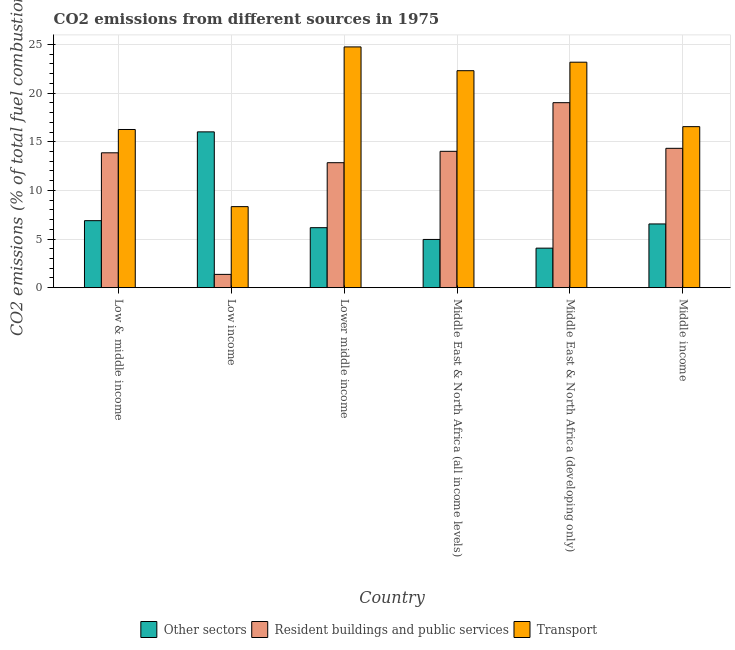How many different coloured bars are there?
Offer a very short reply. 3. In how many cases, is the number of bars for a given country not equal to the number of legend labels?
Your response must be concise. 0. What is the percentage of co2 emissions from transport in Low income?
Ensure brevity in your answer.  8.33. Across all countries, what is the maximum percentage of co2 emissions from transport?
Offer a very short reply. 24.75. Across all countries, what is the minimum percentage of co2 emissions from transport?
Your answer should be very brief. 8.33. In which country was the percentage of co2 emissions from resident buildings and public services maximum?
Provide a succinct answer. Middle East & North Africa (developing only). In which country was the percentage of co2 emissions from other sectors minimum?
Ensure brevity in your answer.  Middle East & North Africa (developing only). What is the total percentage of co2 emissions from transport in the graph?
Make the answer very short. 111.37. What is the difference between the percentage of co2 emissions from transport in Middle East & North Africa (all income levels) and that in Middle East & North Africa (developing only)?
Ensure brevity in your answer.  -0.87. What is the difference between the percentage of co2 emissions from other sectors in Low income and the percentage of co2 emissions from transport in Middle income?
Your answer should be compact. -0.54. What is the average percentage of co2 emissions from other sectors per country?
Your response must be concise. 7.44. What is the difference between the percentage of co2 emissions from resident buildings and public services and percentage of co2 emissions from other sectors in Low income?
Your answer should be very brief. -14.65. What is the ratio of the percentage of co2 emissions from transport in Low & middle income to that in Middle income?
Give a very brief answer. 0.98. What is the difference between the highest and the second highest percentage of co2 emissions from transport?
Ensure brevity in your answer.  1.57. What is the difference between the highest and the lowest percentage of co2 emissions from resident buildings and public services?
Make the answer very short. 17.65. In how many countries, is the percentage of co2 emissions from transport greater than the average percentage of co2 emissions from transport taken over all countries?
Offer a very short reply. 3. What does the 1st bar from the left in Middle East & North Africa (all income levels) represents?
Offer a very short reply. Other sectors. What does the 2nd bar from the right in Lower middle income represents?
Keep it short and to the point. Resident buildings and public services. How many bars are there?
Give a very brief answer. 18. Are the values on the major ticks of Y-axis written in scientific E-notation?
Offer a terse response. No. Where does the legend appear in the graph?
Provide a short and direct response. Bottom center. How many legend labels are there?
Offer a very short reply. 3. How are the legend labels stacked?
Your answer should be very brief. Horizontal. What is the title of the graph?
Give a very brief answer. CO2 emissions from different sources in 1975. What is the label or title of the Y-axis?
Give a very brief answer. CO2 emissions (% of total fuel combustion). What is the CO2 emissions (% of total fuel combustion) of Other sectors in Low & middle income?
Offer a terse response. 6.89. What is the CO2 emissions (% of total fuel combustion) of Resident buildings and public services in Low & middle income?
Your answer should be compact. 13.86. What is the CO2 emissions (% of total fuel combustion) of Transport in Low & middle income?
Keep it short and to the point. 16.26. What is the CO2 emissions (% of total fuel combustion) of Other sectors in Low income?
Provide a succinct answer. 16.01. What is the CO2 emissions (% of total fuel combustion) in Resident buildings and public services in Low income?
Offer a terse response. 1.37. What is the CO2 emissions (% of total fuel combustion) in Transport in Low income?
Your response must be concise. 8.33. What is the CO2 emissions (% of total fuel combustion) in Other sectors in Lower middle income?
Keep it short and to the point. 6.17. What is the CO2 emissions (% of total fuel combustion) in Resident buildings and public services in Lower middle income?
Your answer should be compact. 12.85. What is the CO2 emissions (% of total fuel combustion) of Transport in Lower middle income?
Provide a succinct answer. 24.75. What is the CO2 emissions (% of total fuel combustion) in Other sectors in Middle East & North Africa (all income levels)?
Provide a succinct answer. 4.96. What is the CO2 emissions (% of total fuel combustion) in Resident buildings and public services in Middle East & North Africa (all income levels)?
Your answer should be compact. 14.01. What is the CO2 emissions (% of total fuel combustion) of Transport in Middle East & North Africa (all income levels)?
Offer a very short reply. 22.3. What is the CO2 emissions (% of total fuel combustion) of Other sectors in Middle East & North Africa (developing only)?
Give a very brief answer. 4.06. What is the CO2 emissions (% of total fuel combustion) of Resident buildings and public services in Middle East & North Africa (developing only)?
Your answer should be very brief. 19.01. What is the CO2 emissions (% of total fuel combustion) of Transport in Middle East & North Africa (developing only)?
Provide a succinct answer. 23.18. What is the CO2 emissions (% of total fuel combustion) in Other sectors in Middle income?
Your response must be concise. 6.55. What is the CO2 emissions (% of total fuel combustion) in Resident buildings and public services in Middle income?
Provide a succinct answer. 14.32. What is the CO2 emissions (% of total fuel combustion) of Transport in Middle income?
Ensure brevity in your answer.  16.55. Across all countries, what is the maximum CO2 emissions (% of total fuel combustion) of Other sectors?
Your answer should be very brief. 16.01. Across all countries, what is the maximum CO2 emissions (% of total fuel combustion) of Resident buildings and public services?
Provide a short and direct response. 19.01. Across all countries, what is the maximum CO2 emissions (% of total fuel combustion) of Transport?
Make the answer very short. 24.75. Across all countries, what is the minimum CO2 emissions (% of total fuel combustion) in Other sectors?
Provide a succinct answer. 4.06. Across all countries, what is the minimum CO2 emissions (% of total fuel combustion) of Resident buildings and public services?
Ensure brevity in your answer.  1.37. Across all countries, what is the minimum CO2 emissions (% of total fuel combustion) in Transport?
Provide a short and direct response. 8.33. What is the total CO2 emissions (% of total fuel combustion) of Other sectors in the graph?
Give a very brief answer. 44.64. What is the total CO2 emissions (% of total fuel combustion) in Resident buildings and public services in the graph?
Make the answer very short. 75.43. What is the total CO2 emissions (% of total fuel combustion) of Transport in the graph?
Your answer should be very brief. 111.37. What is the difference between the CO2 emissions (% of total fuel combustion) of Other sectors in Low & middle income and that in Low income?
Offer a terse response. -9.13. What is the difference between the CO2 emissions (% of total fuel combustion) of Resident buildings and public services in Low & middle income and that in Low income?
Offer a very short reply. 12.5. What is the difference between the CO2 emissions (% of total fuel combustion) in Transport in Low & middle income and that in Low income?
Offer a terse response. 7.93. What is the difference between the CO2 emissions (% of total fuel combustion) of Other sectors in Low & middle income and that in Lower middle income?
Give a very brief answer. 0.72. What is the difference between the CO2 emissions (% of total fuel combustion) of Resident buildings and public services in Low & middle income and that in Lower middle income?
Ensure brevity in your answer.  1.02. What is the difference between the CO2 emissions (% of total fuel combustion) in Transport in Low & middle income and that in Lower middle income?
Make the answer very short. -8.49. What is the difference between the CO2 emissions (% of total fuel combustion) in Other sectors in Low & middle income and that in Middle East & North Africa (all income levels)?
Ensure brevity in your answer.  1.93. What is the difference between the CO2 emissions (% of total fuel combustion) in Resident buildings and public services in Low & middle income and that in Middle East & North Africa (all income levels)?
Your answer should be compact. -0.15. What is the difference between the CO2 emissions (% of total fuel combustion) of Transport in Low & middle income and that in Middle East & North Africa (all income levels)?
Offer a terse response. -6.04. What is the difference between the CO2 emissions (% of total fuel combustion) in Other sectors in Low & middle income and that in Middle East & North Africa (developing only)?
Offer a terse response. 2.82. What is the difference between the CO2 emissions (% of total fuel combustion) in Resident buildings and public services in Low & middle income and that in Middle East & North Africa (developing only)?
Ensure brevity in your answer.  -5.15. What is the difference between the CO2 emissions (% of total fuel combustion) of Transport in Low & middle income and that in Middle East & North Africa (developing only)?
Make the answer very short. -6.92. What is the difference between the CO2 emissions (% of total fuel combustion) of Other sectors in Low & middle income and that in Middle income?
Provide a succinct answer. 0.34. What is the difference between the CO2 emissions (% of total fuel combustion) in Resident buildings and public services in Low & middle income and that in Middle income?
Make the answer very short. -0.46. What is the difference between the CO2 emissions (% of total fuel combustion) of Transport in Low & middle income and that in Middle income?
Your answer should be very brief. -0.29. What is the difference between the CO2 emissions (% of total fuel combustion) in Other sectors in Low income and that in Lower middle income?
Keep it short and to the point. 9.85. What is the difference between the CO2 emissions (% of total fuel combustion) in Resident buildings and public services in Low income and that in Lower middle income?
Ensure brevity in your answer.  -11.48. What is the difference between the CO2 emissions (% of total fuel combustion) of Transport in Low income and that in Lower middle income?
Your answer should be very brief. -16.42. What is the difference between the CO2 emissions (% of total fuel combustion) of Other sectors in Low income and that in Middle East & North Africa (all income levels)?
Your answer should be very brief. 11.06. What is the difference between the CO2 emissions (% of total fuel combustion) of Resident buildings and public services in Low income and that in Middle East & North Africa (all income levels)?
Provide a succinct answer. -12.65. What is the difference between the CO2 emissions (% of total fuel combustion) of Transport in Low income and that in Middle East & North Africa (all income levels)?
Offer a terse response. -13.97. What is the difference between the CO2 emissions (% of total fuel combustion) in Other sectors in Low income and that in Middle East & North Africa (developing only)?
Keep it short and to the point. 11.95. What is the difference between the CO2 emissions (% of total fuel combustion) of Resident buildings and public services in Low income and that in Middle East & North Africa (developing only)?
Ensure brevity in your answer.  -17.65. What is the difference between the CO2 emissions (% of total fuel combustion) in Transport in Low income and that in Middle East & North Africa (developing only)?
Your answer should be very brief. -14.85. What is the difference between the CO2 emissions (% of total fuel combustion) of Other sectors in Low income and that in Middle income?
Your response must be concise. 9.46. What is the difference between the CO2 emissions (% of total fuel combustion) in Resident buildings and public services in Low income and that in Middle income?
Your response must be concise. -12.96. What is the difference between the CO2 emissions (% of total fuel combustion) of Transport in Low income and that in Middle income?
Give a very brief answer. -8.22. What is the difference between the CO2 emissions (% of total fuel combustion) in Other sectors in Lower middle income and that in Middle East & North Africa (all income levels)?
Your answer should be compact. 1.21. What is the difference between the CO2 emissions (% of total fuel combustion) in Resident buildings and public services in Lower middle income and that in Middle East & North Africa (all income levels)?
Your response must be concise. -1.17. What is the difference between the CO2 emissions (% of total fuel combustion) in Transport in Lower middle income and that in Middle East & North Africa (all income levels)?
Offer a terse response. 2.44. What is the difference between the CO2 emissions (% of total fuel combustion) of Other sectors in Lower middle income and that in Middle East & North Africa (developing only)?
Keep it short and to the point. 2.1. What is the difference between the CO2 emissions (% of total fuel combustion) of Resident buildings and public services in Lower middle income and that in Middle East & North Africa (developing only)?
Your answer should be compact. -6.17. What is the difference between the CO2 emissions (% of total fuel combustion) in Transport in Lower middle income and that in Middle East & North Africa (developing only)?
Your response must be concise. 1.57. What is the difference between the CO2 emissions (% of total fuel combustion) in Other sectors in Lower middle income and that in Middle income?
Offer a terse response. -0.38. What is the difference between the CO2 emissions (% of total fuel combustion) of Resident buildings and public services in Lower middle income and that in Middle income?
Your answer should be very brief. -1.48. What is the difference between the CO2 emissions (% of total fuel combustion) in Transport in Lower middle income and that in Middle income?
Provide a succinct answer. 8.2. What is the difference between the CO2 emissions (% of total fuel combustion) in Other sectors in Middle East & North Africa (all income levels) and that in Middle East & North Africa (developing only)?
Your answer should be compact. 0.89. What is the difference between the CO2 emissions (% of total fuel combustion) of Resident buildings and public services in Middle East & North Africa (all income levels) and that in Middle East & North Africa (developing only)?
Your response must be concise. -5. What is the difference between the CO2 emissions (% of total fuel combustion) in Transport in Middle East & North Africa (all income levels) and that in Middle East & North Africa (developing only)?
Keep it short and to the point. -0.87. What is the difference between the CO2 emissions (% of total fuel combustion) of Other sectors in Middle East & North Africa (all income levels) and that in Middle income?
Ensure brevity in your answer.  -1.59. What is the difference between the CO2 emissions (% of total fuel combustion) of Resident buildings and public services in Middle East & North Africa (all income levels) and that in Middle income?
Your response must be concise. -0.31. What is the difference between the CO2 emissions (% of total fuel combustion) of Transport in Middle East & North Africa (all income levels) and that in Middle income?
Provide a succinct answer. 5.75. What is the difference between the CO2 emissions (% of total fuel combustion) of Other sectors in Middle East & North Africa (developing only) and that in Middle income?
Keep it short and to the point. -2.49. What is the difference between the CO2 emissions (% of total fuel combustion) of Resident buildings and public services in Middle East & North Africa (developing only) and that in Middle income?
Your answer should be compact. 4.69. What is the difference between the CO2 emissions (% of total fuel combustion) of Transport in Middle East & North Africa (developing only) and that in Middle income?
Provide a short and direct response. 6.63. What is the difference between the CO2 emissions (% of total fuel combustion) in Other sectors in Low & middle income and the CO2 emissions (% of total fuel combustion) in Resident buildings and public services in Low income?
Your answer should be compact. 5.52. What is the difference between the CO2 emissions (% of total fuel combustion) of Other sectors in Low & middle income and the CO2 emissions (% of total fuel combustion) of Transport in Low income?
Offer a very short reply. -1.44. What is the difference between the CO2 emissions (% of total fuel combustion) in Resident buildings and public services in Low & middle income and the CO2 emissions (% of total fuel combustion) in Transport in Low income?
Provide a succinct answer. 5.53. What is the difference between the CO2 emissions (% of total fuel combustion) of Other sectors in Low & middle income and the CO2 emissions (% of total fuel combustion) of Resident buildings and public services in Lower middle income?
Ensure brevity in your answer.  -5.96. What is the difference between the CO2 emissions (% of total fuel combustion) in Other sectors in Low & middle income and the CO2 emissions (% of total fuel combustion) in Transport in Lower middle income?
Offer a very short reply. -17.86. What is the difference between the CO2 emissions (% of total fuel combustion) of Resident buildings and public services in Low & middle income and the CO2 emissions (% of total fuel combustion) of Transport in Lower middle income?
Provide a short and direct response. -10.88. What is the difference between the CO2 emissions (% of total fuel combustion) of Other sectors in Low & middle income and the CO2 emissions (% of total fuel combustion) of Resident buildings and public services in Middle East & North Africa (all income levels)?
Ensure brevity in your answer.  -7.13. What is the difference between the CO2 emissions (% of total fuel combustion) in Other sectors in Low & middle income and the CO2 emissions (% of total fuel combustion) in Transport in Middle East & North Africa (all income levels)?
Offer a terse response. -15.42. What is the difference between the CO2 emissions (% of total fuel combustion) in Resident buildings and public services in Low & middle income and the CO2 emissions (% of total fuel combustion) in Transport in Middle East & North Africa (all income levels)?
Offer a terse response. -8.44. What is the difference between the CO2 emissions (% of total fuel combustion) in Other sectors in Low & middle income and the CO2 emissions (% of total fuel combustion) in Resident buildings and public services in Middle East & North Africa (developing only)?
Ensure brevity in your answer.  -12.13. What is the difference between the CO2 emissions (% of total fuel combustion) in Other sectors in Low & middle income and the CO2 emissions (% of total fuel combustion) in Transport in Middle East & North Africa (developing only)?
Offer a terse response. -16.29. What is the difference between the CO2 emissions (% of total fuel combustion) in Resident buildings and public services in Low & middle income and the CO2 emissions (% of total fuel combustion) in Transport in Middle East & North Africa (developing only)?
Your response must be concise. -9.31. What is the difference between the CO2 emissions (% of total fuel combustion) in Other sectors in Low & middle income and the CO2 emissions (% of total fuel combustion) in Resident buildings and public services in Middle income?
Provide a short and direct response. -7.44. What is the difference between the CO2 emissions (% of total fuel combustion) in Other sectors in Low & middle income and the CO2 emissions (% of total fuel combustion) in Transport in Middle income?
Your response must be concise. -9.66. What is the difference between the CO2 emissions (% of total fuel combustion) of Resident buildings and public services in Low & middle income and the CO2 emissions (% of total fuel combustion) of Transport in Middle income?
Give a very brief answer. -2.69. What is the difference between the CO2 emissions (% of total fuel combustion) in Other sectors in Low income and the CO2 emissions (% of total fuel combustion) in Resident buildings and public services in Lower middle income?
Ensure brevity in your answer.  3.17. What is the difference between the CO2 emissions (% of total fuel combustion) of Other sectors in Low income and the CO2 emissions (% of total fuel combustion) of Transport in Lower middle income?
Offer a terse response. -8.73. What is the difference between the CO2 emissions (% of total fuel combustion) in Resident buildings and public services in Low income and the CO2 emissions (% of total fuel combustion) in Transport in Lower middle income?
Ensure brevity in your answer.  -23.38. What is the difference between the CO2 emissions (% of total fuel combustion) in Other sectors in Low income and the CO2 emissions (% of total fuel combustion) in Resident buildings and public services in Middle East & North Africa (all income levels)?
Your answer should be very brief. 2. What is the difference between the CO2 emissions (% of total fuel combustion) of Other sectors in Low income and the CO2 emissions (% of total fuel combustion) of Transport in Middle East & North Africa (all income levels)?
Keep it short and to the point. -6.29. What is the difference between the CO2 emissions (% of total fuel combustion) of Resident buildings and public services in Low income and the CO2 emissions (% of total fuel combustion) of Transport in Middle East & North Africa (all income levels)?
Ensure brevity in your answer.  -20.94. What is the difference between the CO2 emissions (% of total fuel combustion) of Other sectors in Low income and the CO2 emissions (% of total fuel combustion) of Resident buildings and public services in Middle East & North Africa (developing only)?
Your response must be concise. -3. What is the difference between the CO2 emissions (% of total fuel combustion) in Other sectors in Low income and the CO2 emissions (% of total fuel combustion) in Transport in Middle East & North Africa (developing only)?
Your answer should be very brief. -7.16. What is the difference between the CO2 emissions (% of total fuel combustion) in Resident buildings and public services in Low income and the CO2 emissions (% of total fuel combustion) in Transport in Middle East & North Africa (developing only)?
Make the answer very short. -21.81. What is the difference between the CO2 emissions (% of total fuel combustion) in Other sectors in Low income and the CO2 emissions (% of total fuel combustion) in Resident buildings and public services in Middle income?
Your response must be concise. 1.69. What is the difference between the CO2 emissions (% of total fuel combustion) of Other sectors in Low income and the CO2 emissions (% of total fuel combustion) of Transport in Middle income?
Make the answer very short. -0.54. What is the difference between the CO2 emissions (% of total fuel combustion) of Resident buildings and public services in Low income and the CO2 emissions (% of total fuel combustion) of Transport in Middle income?
Give a very brief answer. -15.19. What is the difference between the CO2 emissions (% of total fuel combustion) of Other sectors in Lower middle income and the CO2 emissions (% of total fuel combustion) of Resident buildings and public services in Middle East & North Africa (all income levels)?
Provide a short and direct response. -7.85. What is the difference between the CO2 emissions (% of total fuel combustion) in Other sectors in Lower middle income and the CO2 emissions (% of total fuel combustion) in Transport in Middle East & North Africa (all income levels)?
Your answer should be very brief. -16.14. What is the difference between the CO2 emissions (% of total fuel combustion) of Resident buildings and public services in Lower middle income and the CO2 emissions (% of total fuel combustion) of Transport in Middle East & North Africa (all income levels)?
Make the answer very short. -9.46. What is the difference between the CO2 emissions (% of total fuel combustion) in Other sectors in Lower middle income and the CO2 emissions (% of total fuel combustion) in Resident buildings and public services in Middle East & North Africa (developing only)?
Offer a very short reply. -12.85. What is the difference between the CO2 emissions (% of total fuel combustion) in Other sectors in Lower middle income and the CO2 emissions (% of total fuel combustion) in Transport in Middle East & North Africa (developing only)?
Ensure brevity in your answer.  -17.01. What is the difference between the CO2 emissions (% of total fuel combustion) in Resident buildings and public services in Lower middle income and the CO2 emissions (% of total fuel combustion) in Transport in Middle East & North Africa (developing only)?
Provide a short and direct response. -10.33. What is the difference between the CO2 emissions (% of total fuel combustion) in Other sectors in Lower middle income and the CO2 emissions (% of total fuel combustion) in Resident buildings and public services in Middle income?
Provide a short and direct response. -8.16. What is the difference between the CO2 emissions (% of total fuel combustion) of Other sectors in Lower middle income and the CO2 emissions (% of total fuel combustion) of Transport in Middle income?
Your answer should be compact. -10.39. What is the difference between the CO2 emissions (% of total fuel combustion) of Resident buildings and public services in Lower middle income and the CO2 emissions (% of total fuel combustion) of Transport in Middle income?
Provide a short and direct response. -3.71. What is the difference between the CO2 emissions (% of total fuel combustion) in Other sectors in Middle East & North Africa (all income levels) and the CO2 emissions (% of total fuel combustion) in Resident buildings and public services in Middle East & North Africa (developing only)?
Make the answer very short. -14.06. What is the difference between the CO2 emissions (% of total fuel combustion) of Other sectors in Middle East & North Africa (all income levels) and the CO2 emissions (% of total fuel combustion) of Transport in Middle East & North Africa (developing only)?
Your response must be concise. -18.22. What is the difference between the CO2 emissions (% of total fuel combustion) of Resident buildings and public services in Middle East & North Africa (all income levels) and the CO2 emissions (% of total fuel combustion) of Transport in Middle East & North Africa (developing only)?
Your response must be concise. -9.16. What is the difference between the CO2 emissions (% of total fuel combustion) in Other sectors in Middle East & North Africa (all income levels) and the CO2 emissions (% of total fuel combustion) in Resident buildings and public services in Middle income?
Give a very brief answer. -9.37. What is the difference between the CO2 emissions (% of total fuel combustion) in Other sectors in Middle East & North Africa (all income levels) and the CO2 emissions (% of total fuel combustion) in Transport in Middle income?
Make the answer very short. -11.59. What is the difference between the CO2 emissions (% of total fuel combustion) of Resident buildings and public services in Middle East & North Africa (all income levels) and the CO2 emissions (% of total fuel combustion) of Transport in Middle income?
Keep it short and to the point. -2.54. What is the difference between the CO2 emissions (% of total fuel combustion) in Other sectors in Middle East & North Africa (developing only) and the CO2 emissions (% of total fuel combustion) in Resident buildings and public services in Middle income?
Make the answer very short. -10.26. What is the difference between the CO2 emissions (% of total fuel combustion) of Other sectors in Middle East & North Africa (developing only) and the CO2 emissions (% of total fuel combustion) of Transport in Middle income?
Ensure brevity in your answer.  -12.49. What is the difference between the CO2 emissions (% of total fuel combustion) in Resident buildings and public services in Middle East & North Africa (developing only) and the CO2 emissions (% of total fuel combustion) in Transport in Middle income?
Make the answer very short. 2.46. What is the average CO2 emissions (% of total fuel combustion) in Other sectors per country?
Your answer should be very brief. 7.44. What is the average CO2 emissions (% of total fuel combustion) of Resident buildings and public services per country?
Make the answer very short. 12.57. What is the average CO2 emissions (% of total fuel combustion) of Transport per country?
Your answer should be very brief. 18.56. What is the difference between the CO2 emissions (% of total fuel combustion) in Other sectors and CO2 emissions (% of total fuel combustion) in Resident buildings and public services in Low & middle income?
Offer a terse response. -6.98. What is the difference between the CO2 emissions (% of total fuel combustion) in Other sectors and CO2 emissions (% of total fuel combustion) in Transport in Low & middle income?
Provide a succinct answer. -9.37. What is the difference between the CO2 emissions (% of total fuel combustion) of Resident buildings and public services and CO2 emissions (% of total fuel combustion) of Transport in Low & middle income?
Provide a short and direct response. -2.4. What is the difference between the CO2 emissions (% of total fuel combustion) of Other sectors and CO2 emissions (% of total fuel combustion) of Resident buildings and public services in Low income?
Give a very brief answer. 14.65. What is the difference between the CO2 emissions (% of total fuel combustion) of Other sectors and CO2 emissions (% of total fuel combustion) of Transport in Low income?
Ensure brevity in your answer.  7.68. What is the difference between the CO2 emissions (% of total fuel combustion) of Resident buildings and public services and CO2 emissions (% of total fuel combustion) of Transport in Low income?
Provide a succinct answer. -6.96. What is the difference between the CO2 emissions (% of total fuel combustion) of Other sectors and CO2 emissions (% of total fuel combustion) of Resident buildings and public services in Lower middle income?
Offer a very short reply. -6.68. What is the difference between the CO2 emissions (% of total fuel combustion) of Other sectors and CO2 emissions (% of total fuel combustion) of Transport in Lower middle income?
Make the answer very short. -18.58. What is the difference between the CO2 emissions (% of total fuel combustion) of Resident buildings and public services and CO2 emissions (% of total fuel combustion) of Transport in Lower middle income?
Provide a succinct answer. -11.9. What is the difference between the CO2 emissions (% of total fuel combustion) of Other sectors and CO2 emissions (% of total fuel combustion) of Resident buildings and public services in Middle East & North Africa (all income levels)?
Your response must be concise. -9.06. What is the difference between the CO2 emissions (% of total fuel combustion) of Other sectors and CO2 emissions (% of total fuel combustion) of Transport in Middle East & North Africa (all income levels)?
Give a very brief answer. -17.35. What is the difference between the CO2 emissions (% of total fuel combustion) of Resident buildings and public services and CO2 emissions (% of total fuel combustion) of Transport in Middle East & North Africa (all income levels)?
Your answer should be compact. -8.29. What is the difference between the CO2 emissions (% of total fuel combustion) in Other sectors and CO2 emissions (% of total fuel combustion) in Resident buildings and public services in Middle East & North Africa (developing only)?
Your response must be concise. -14.95. What is the difference between the CO2 emissions (% of total fuel combustion) in Other sectors and CO2 emissions (% of total fuel combustion) in Transport in Middle East & North Africa (developing only)?
Make the answer very short. -19.11. What is the difference between the CO2 emissions (% of total fuel combustion) in Resident buildings and public services and CO2 emissions (% of total fuel combustion) in Transport in Middle East & North Africa (developing only)?
Provide a short and direct response. -4.16. What is the difference between the CO2 emissions (% of total fuel combustion) of Other sectors and CO2 emissions (% of total fuel combustion) of Resident buildings and public services in Middle income?
Offer a very short reply. -7.77. What is the difference between the CO2 emissions (% of total fuel combustion) in Other sectors and CO2 emissions (% of total fuel combustion) in Transport in Middle income?
Your response must be concise. -10. What is the difference between the CO2 emissions (% of total fuel combustion) of Resident buildings and public services and CO2 emissions (% of total fuel combustion) of Transport in Middle income?
Keep it short and to the point. -2.23. What is the ratio of the CO2 emissions (% of total fuel combustion) of Other sectors in Low & middle income to that in Low income?
Your response must be concise. 0.43. What is the ratio of the CO2 emissions (% of total fuel combustion) of Resident buildings and public services in Low & middle income to that in Low income?
Your answer should be compact. 10.16. What is the ratio of the CO2 emissions (% of total fuel combustion) in Transport in Low & middle income to that in Low income?
Provide a succinct answer. 1.95. What is the ratio of the CO2 emissions (% of total fuel combustion) of Other sectors in Low & middle income to that in Lower middle income?
Offer a very short reply. 1.12. What is the ratio of the CO2 emissions (% of total fuel combustion) of Resident buildings and public services in Low & middle income to that in Lower middle income?
Ensure brevity in your answer.  1.08. What is the ratio of the CO2 emissions (% of total fuel combustion) in Transport in Low & middle income to that in Lower middle income?
Offer a very short reply. 0.66. What is the ratio of the CO2 emissions (% of total fuel combustion) in Other sectors in Low & middle income to that in Middle East & North Africa (all income levels)?
Ensure brevity in your answer.  1.39. What is the ratio of the CO2 emissions (% of total fuel combustion) in Transport in Low & middle income to that in Middle East & North Africa (all income levels)?
Offer a very short reply. 0.73. What is the ratio of the CO2 emissions (% of total fuel combustion) in Other sectors in Low & middle income to that in Middle East & North Africa (developing only)?
Your response must be concise. 1.7. What is the ratio of the CO2 emissions (% of total fuel combustion) of Resident buildings and public services in Low & middle income to that in Middle East & North Africa (developing only)?
Offer a terse response. 0.73. What is the ratio of the CO2 emissions (% of total fuel combustion) in Transport in Low & middle income to that in Middle East & North Africa (developing only)?
Your answer should be compact. 0.7. What is the ratio of the CO2 emissions (% of total fuel combustion) in Other sectors in Low & middle income to that in Middle income?
Provide a short and direct response. 1.05. What is the ratio of the CO2 emissions (% of total fuel combustion) of Resident buildings and public services in Low & middle income to that in Middle income?
Ensure brevity in your answer.  0.97. What is the ratio of the CO2 emissions (% of total fuel combustion) of Transport in Low & middle income to that in Middle income?
Offer a very short reply. 0.98. What is the ratio of the CO2 emissions (% of total fuel combustion) in Other sectors in Low income to that in Lower middle income?
Provide a succinct answer. 2.6. What is the ratio of the CO2 emissions (% of total fuel combustion) in Resident buildings and public services in Low income to that in Lower middle income?
Your answer should be compact. 0.11. What is the ratio of the CO2 emissions (% of total fuel combustion) of Transport in Low income to that in Lower middle income?
Offer a terse response. 0.34. What is the ratio of the CO2 emissions (% of total fuel combustion) in Other sectors in Low income to that in Middle East & North Africa (all income levels)?
Keep it short and to the point. 3.23. What is the ratio of the CO2 emissions (% of total fuel combustion) of Resident buildings and public services in Low income to that in Middle East & North Africa (all income levels)?
Offer a very short reply. 0.1. What is the ratio of the CO2 emissions (% of total fuel combustion) of Transport in Low income to that in Middle East & North Africa (all income levels)?
Your answer should be very brief. 0.37. What is the ratio of the CO2 emissions (% of total fuel combustion) of Other sectors in Low income to that in Middle East & North Africa (developing only)?
Offer a very short reply. 3.94. What is the ratio of the CO2 emissions (% of total fuel combustion) of Resident buildings and public services in Low income to that in Middle East & North Africa (developing only)?
Make the answer very short. 0.07. What is the ratio of the CO2 emissions (% of total fuel combustion) of Transport in Low income to that in Middle East & North Africa (developing only)?
Your response must be concise. 0.36. What is the ratio of the CO2 emissions (% of total fuel combustion) in Other sectors in Low income to that in Middle income?
Keep it short and to the point. 2.44. What is the ratio of the CO2 emissions (% of total fuel combustion) in Resident buildings and public services in Low income to that in Middle income?
Provide a succinct answer. 0.1. What is the ratio of the CO2 emissions (% of total fuel combustion) in Transport in Low income to that in Middle income?
Offer a terse response. 0.5. What is the ratio of the CO2 emissions (% of total fuel combustion) in Other sectors in Lower middle income to that in Middle East & North Africa (all income levels)?
Ensure brevity in your answer.  1.24. What is the ratio of the CO2 emissions (% of total fuel combustion) in Resident buildings and public services in Lower middle income to that in Middle East & North Africa (all income levels)?
Offer a very short reply. 0.92. What is the ratio of the CO2 emissions (% of total fuel combustion) of Transport in Lower middle income to that in Middle East & North Africa (all income levels)?
Make the answer very short. 1.11. What is the ratio of the CO2 emissions (% of total fuel combustion) of Other sectors in Lower middle income to that in Middle East & North Africa (developing only)?
Offer a very short reply. 1.52. What is the ratio of the CO2 emissions (% of total fuel combustion) of Resident buildings and public services in Lower middle income to that in Middle East & North Africa (developing only)?
Offer a terse response. 0.68. What is the ratio of the CO2 emissions (% of total fuel combustion) in Transport in Lower middle income to that in Middle East & North Africa (developing only)?
Your answer should be compact. 1.07. What is the ratio of the CO2 emissions (% of total fuel combustion) of Other sectors in Lower middle income to that in Middle income?
Your answer should be compact. 0.94. What is the ratio of the CO2 emissions (% of total fuel combustion) in Resident buildings and public services in Lower middle income to that in Middle income?
Offer a very short reply. 0.9. What is the ratio of the CO2 emissions (% of total fuel combustion) in Transport in Lower middle income to that in Middle income?
Your answer should be very brief. 1.5. What is the ratio of the CO2 emissions (% of total fuel combustion) in Other sectors in Middle East & North Africa (all income levels) to that in Middle East & North Africa (developing only)?
Your response must be concise. 1.22. What is the ratio of the CO2 emissions (% of total fuel combustion) of Resident buildings and public services in Middle East & North Africa (all income levels) to that in Middle East & North Africa (developing only)?
Offer a very short reply. 0.74. What is the ratio of the CO2 emissions (% of total fuel combustion) of Transport in Middle East & North Africa (all income levels) to that in Middle East & North Africa (developing only)?
Your answer should be compact. 0.96. What is the ratio of the CO2 emissions (% of total fuel combustion) of Other sectors in Middle East & North Africa (all income levels) to that in Middle income?
Ensure brevity in your answer.  0.76. What is the ratio of the CO2 emissions (% of total fuel combustion) of Resident buildings and public services in Middle East & North Africa (all income levels) to that in Middle income?
Give a very brief answer. 0.98. What is the ratio of the CO2 emissions (% of total fuel combustion) of Transport in Middle East & North Africa (all income levels) to that in Middle income?
Keep it short and to the point. 1.35. What is the ratio of the CO2 emissions (% of total fuel combustion) of Other sectors in Middle East & North Africa (developing only) to that in Middle income?
Provide a succinct answer. 0.62. What is the ratio of the CO2 emissions (% of total fuel combustion) in Resident buildings and public services in Middle East & North Africa (developing only) to that in Middle income?
Offer a terse response. 1.33. What is the ratio of the CO2 emissions (% of total fuel combustion) of Transport in Middle East & North Africa (developing only) to that in Middle income?
Your response must be concise. 1.4. What is the difference between the highest and the second highest CO2 emissions (% of total fuel combustion) in Other sectors?
Offer a terse response. 9.13. What is the difference between the highest and the second highest CO2 emissions (% of total fuel combustion) of Resident buildings and public services?
Your answer should be very brief. 4.69. What is the difference between the highest and the second highest CO2 emissions (% of total fuel combustion) of Transport?
Provide a short and direct response. 1.57. What is the difference between the highest and the lowest CO2 emissions (% of total fuel combustion) in Other sectors?
Make the answer very short. 11.95. What is the difference between the highest and the lowest CO2 emissions (% of total fuel combustion) in Resident buildings and public services?
Your response must be concise. 17.65. What is the difference between the highest and the lowest CO2 emissions (% of total fuel combustion) in Transport?
Offer a very short reply. 16.42. 